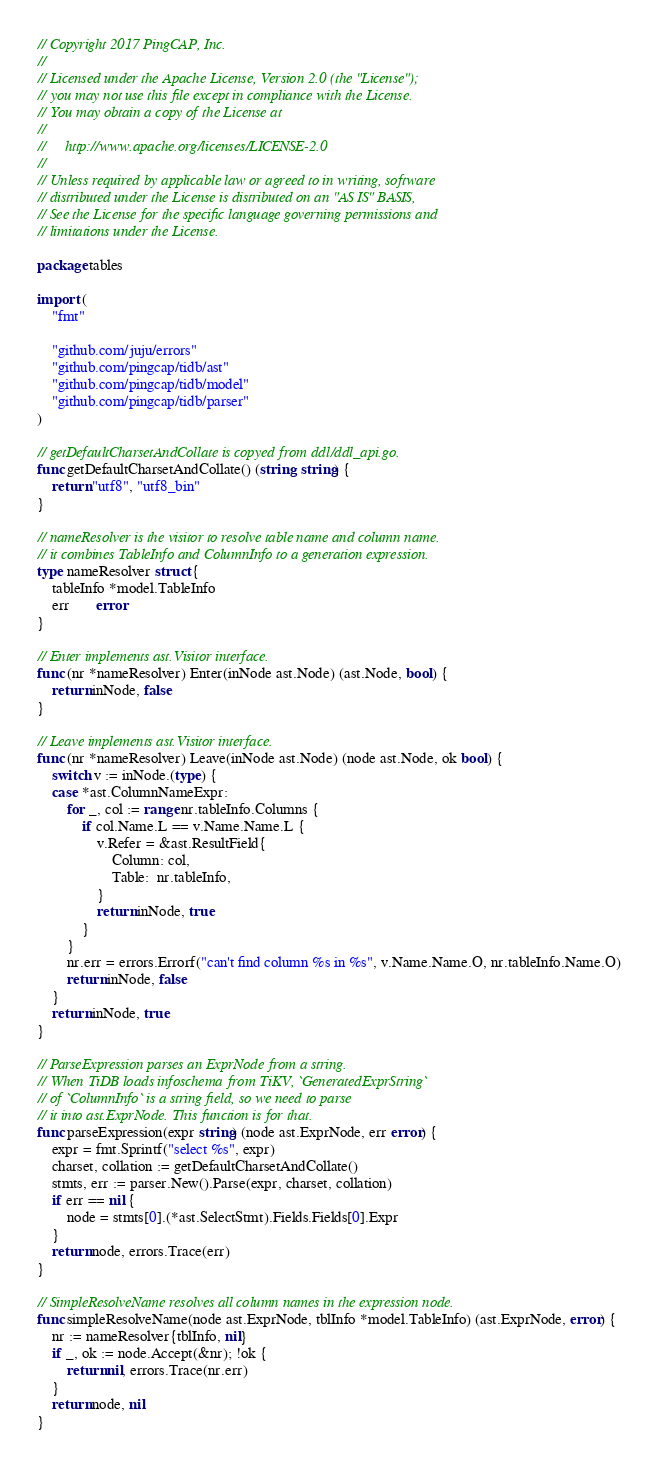<code> <loc_0><loc_0><loc_500><loc_500><_Go_>// Copyright 2017 PingCAP, Inc.
//
// Licensed under the Apache License, Version 2.0 (the "License");
// you may not use this file except in compliance with the License.
// You may obtain a copy of the License at
//
//     http://www.apache.org/licenses/LICENSE-2.0
//
// Unless required by applicable law or agreed to in writing, software
// distributed under the License is distributed on an "AS IS" BASIS,
// See the License for the specific language governing permissions and
// limitations under the License.

package tables

import (
	"fmt"

	"github.com/juju/errors"
	"github.com/pingcap/tidb/ast"
	"github.com/pingcap/tidb/model"
	"github.com/pingcap/tidb/parser"
)

// getDefaultCharsetAndCollate is copyed from ddl/ddl_api.go.
func getDefaultCharsetAndCollate() (string, string) {
	return "utf8", "utf8_bin"
}

// nameResolver is the visitor to resolve table name and column name.
// it combines TableInfo and ColumnInfo to a generation expression.
type nameResolver struct {
	tableInfo *model.TableInfo
	err       error
}

// Enter implements ast.Visitor interface.
func (nr *nameResolver) Enter(inNode ast.Node) (ast.Node, bool) {
	return inNode, false
}

// Leave implements ast.Visitor interface.
func (nr *nameResolver) Leave(inNode ast.Node) (node ast.Node, ok bool) {
	switch v := inNode.(type) {
	case *ast.ColumnNameExpr:
		for _, col := range nr.tableInfo.Columns {
			if col.Name.L == v.Name.Name.L {
				v.Refer = &ast.ResultField{
					Column: col,
					Table:  nr.tableInfo,
				}
				return inNode, true
			}
		}
		nr.err = errors.Errorf("can't find column %s in %s", v.Name.Name.O, nr.tableInfo.Name.O)
		return inNode, false
	}
	return inNode, true
}

// ParseExpression parses an ExprNode from a string.
// When TiDB loads infoschema from TiKV, `GeneratedExprString`
// of `ColumnInfo` is a string field, so we need to parse
// it into ast.ExprNode. This function is for that.
func parseExpression(expr string) (node ast.ExprNode, err error) {
	expr = fmt.Sprintf("select %s", expr)
	charset, collation := getDefaultCharsetAndCollate()
	stmts, err := parser.New().Parse(expr, charset, collation)
	if err == nil {
		node = stmts[0].(*ast.SelectStmt).Fields.Fields[0].Expr
	}
	return node, errors.Trace(err)
}

// SimpleResolveName resolves all column names in the expression node.
func simpleResolveName(node ast.ExprNode, tblInfo *model.TableInfo) (ast.ExprNode, error) {
	nr := nameResolver{tblInfo, nil}
	if _, ok := node.Accept(&nr); !ok {
		return nil, errors.Trace(nr.err)
	}
	return node, nil
}
</code> 